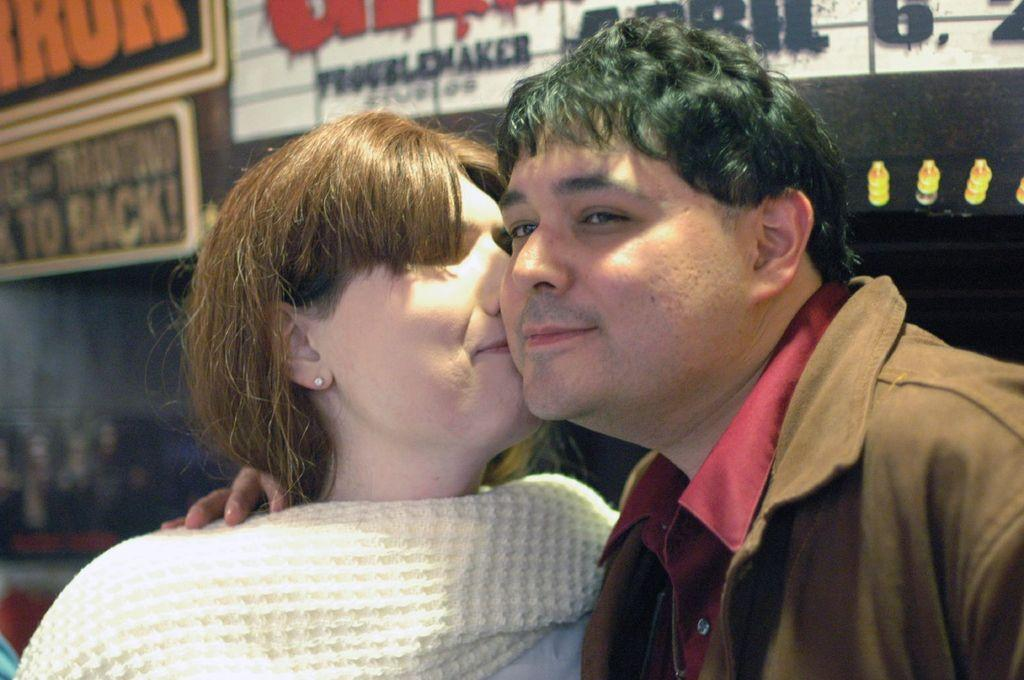Who is in the image? There is a lady in the image. What is the lady doing in the image? The lady is kissing a man in the image. What can be seen in the background of the image? There is a wall in the background of the image. What is on the wall in the image? There are boards on the wall in the image. How many cups are on the bed in the image? There are no cups or beds present in the image. What type of pickle is being used as a prop in the image? There is no pickle present in the image. 